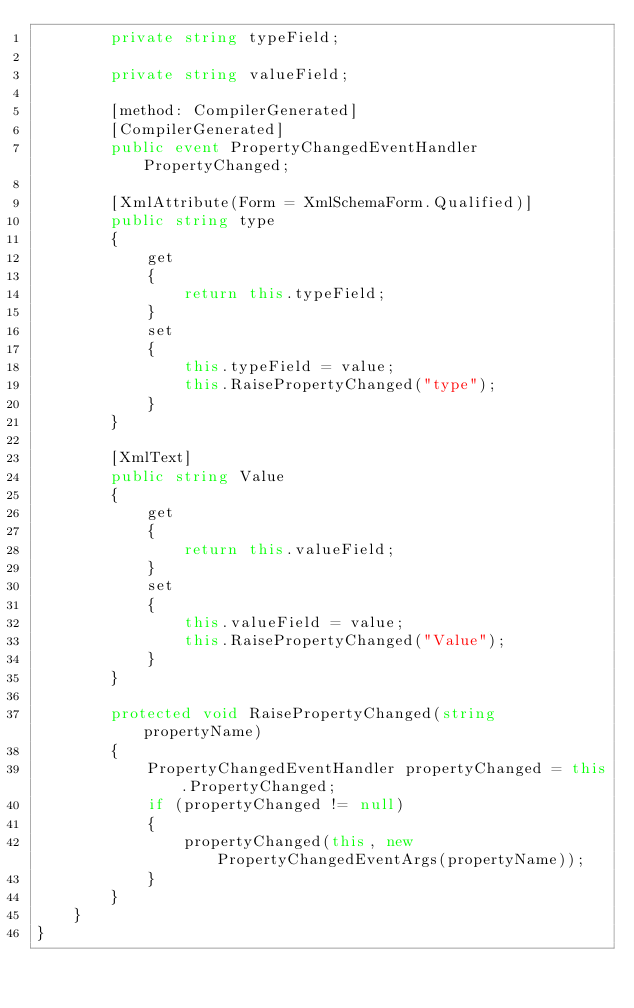Convert code to text. <code><loc_0><loc_0><loc_500><loc_500><_C#_>		private string typeField;

		private string valueField;

		[method: CompilerGenerated]
		[CompilerGenerated]
		public event PropertyChangedEventHandler PropertyChanged;

		[XmlAttribute(Form = XmlSchemaForm.Qualified)]
		public string type
		{
			get
			{
				return this.typeField;
			}
			set
			{
				this.typeField = value;
				this.RaisePropertyChanged("type");
			}
		}

		[XmlText]
		public string Value
		{
			get
			{
				return this.valueField;
			}
			set
			{
				this.valueField = value;
				this.RaisePropertyChanged("Value");
			}
		}

		protected void RaisePropertyChanged(string propertyName)
		{
			PropertyChangedEventHandler propertyChanged = this.PropertyChanged;
			if (propertyChanged != null)
			{
				propertyChanged(this, new PropertyChangedEventArgs(propertyName));
			}
		}
	}
}
</code> 